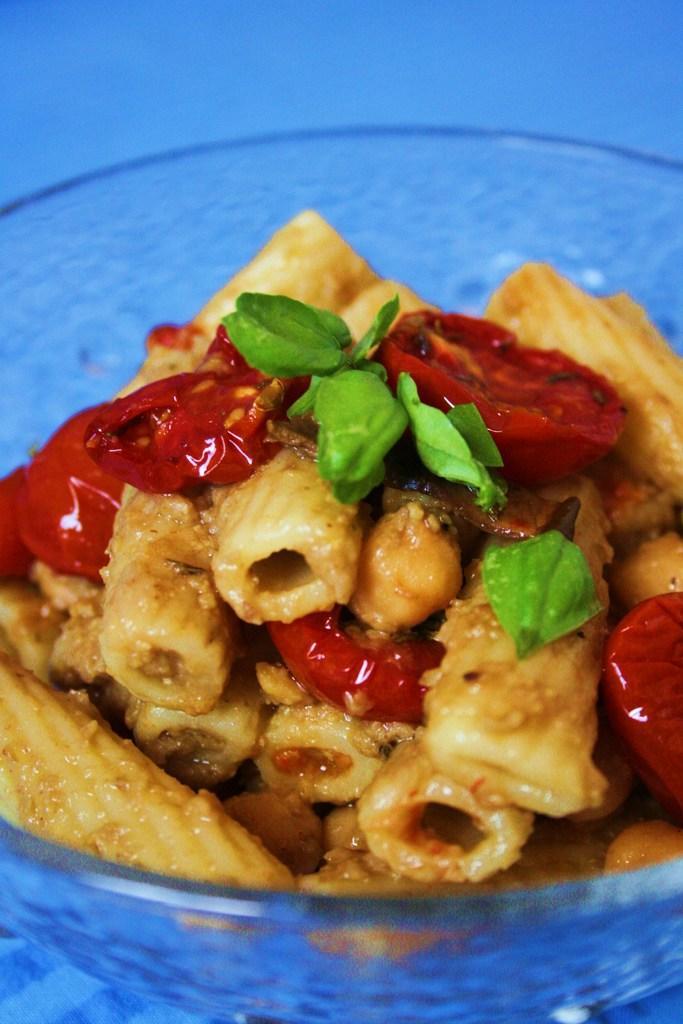Could you give a brief overview of what you see in this image? In this picture I can see a food item in a bowl, on an object. 